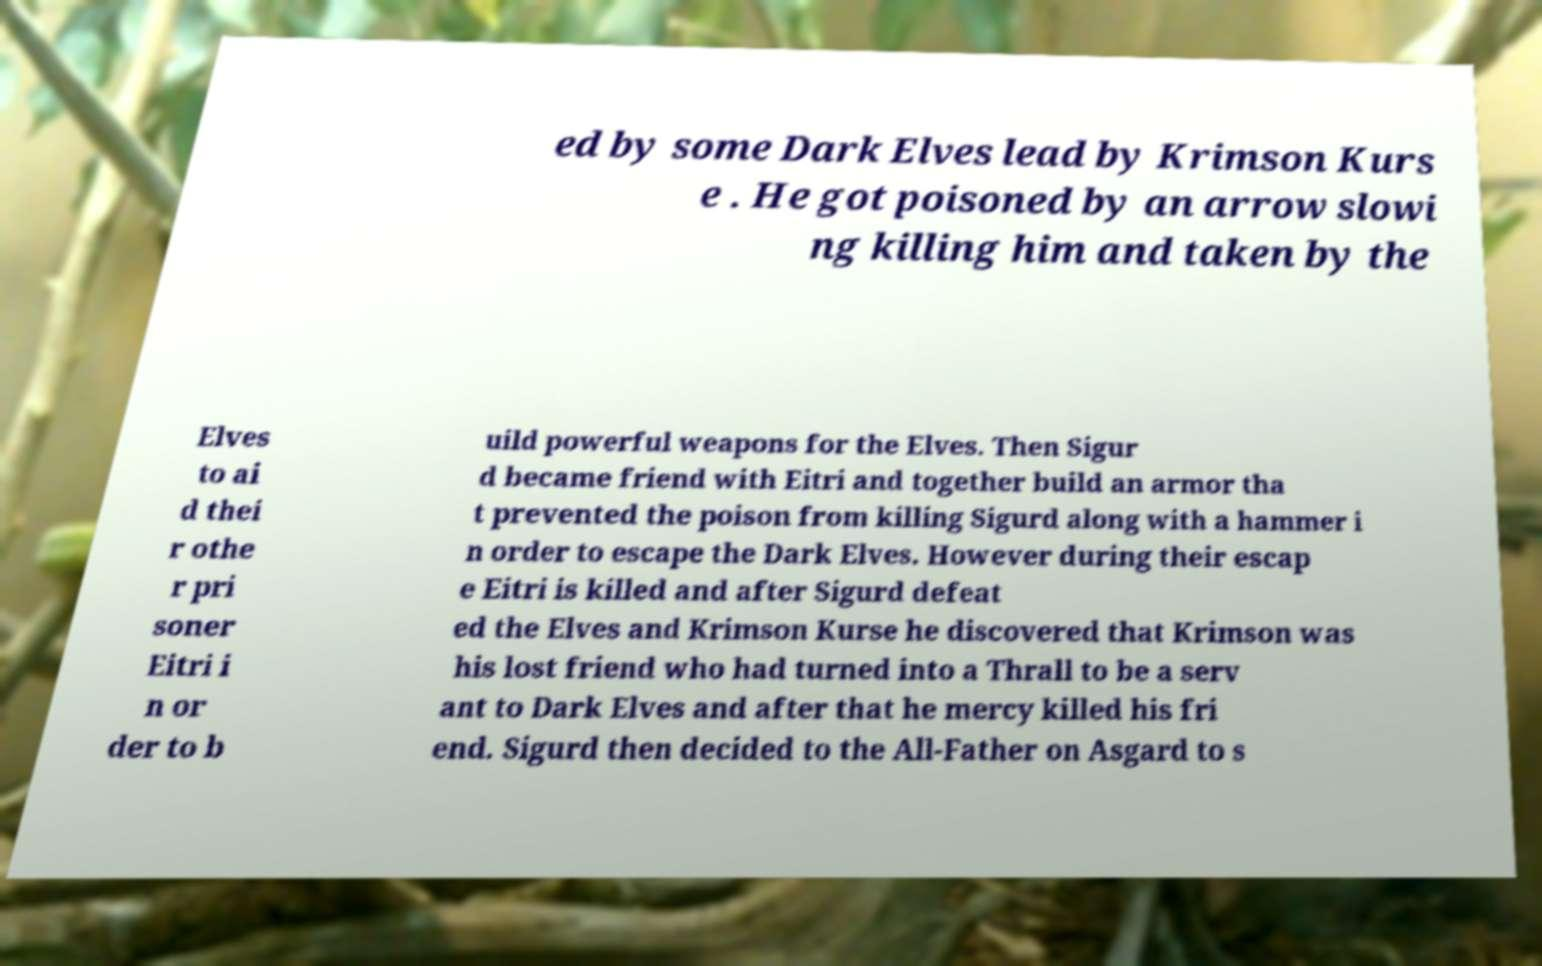What messages or text are displayed in this image? I need them in a readable, typed format. ed by some Dark Elves lead by Krimson Kurs e . He got poisoned by an arrow slowi ng killing him and taken by the Elves to ai d thei r othe r pri soner Eitri i n or der to b uild powerful weapons for the Elves. Then Sigur d became friend with Eitri and together build an armor tha t prevented the poison from killing Sigurd along with a hammer i n order to escape the Dark Elves. However during their escap e Eitri is killed and after Sigurd defeat ed the Elves and Krimson Kurse he discovered that Krimson was his lost friend who had turned into a Thrall to be a serv ant to Dark Elves and after that he mercy killed his fri end. Sigurd then decided to the All-Father on Asgard to s 